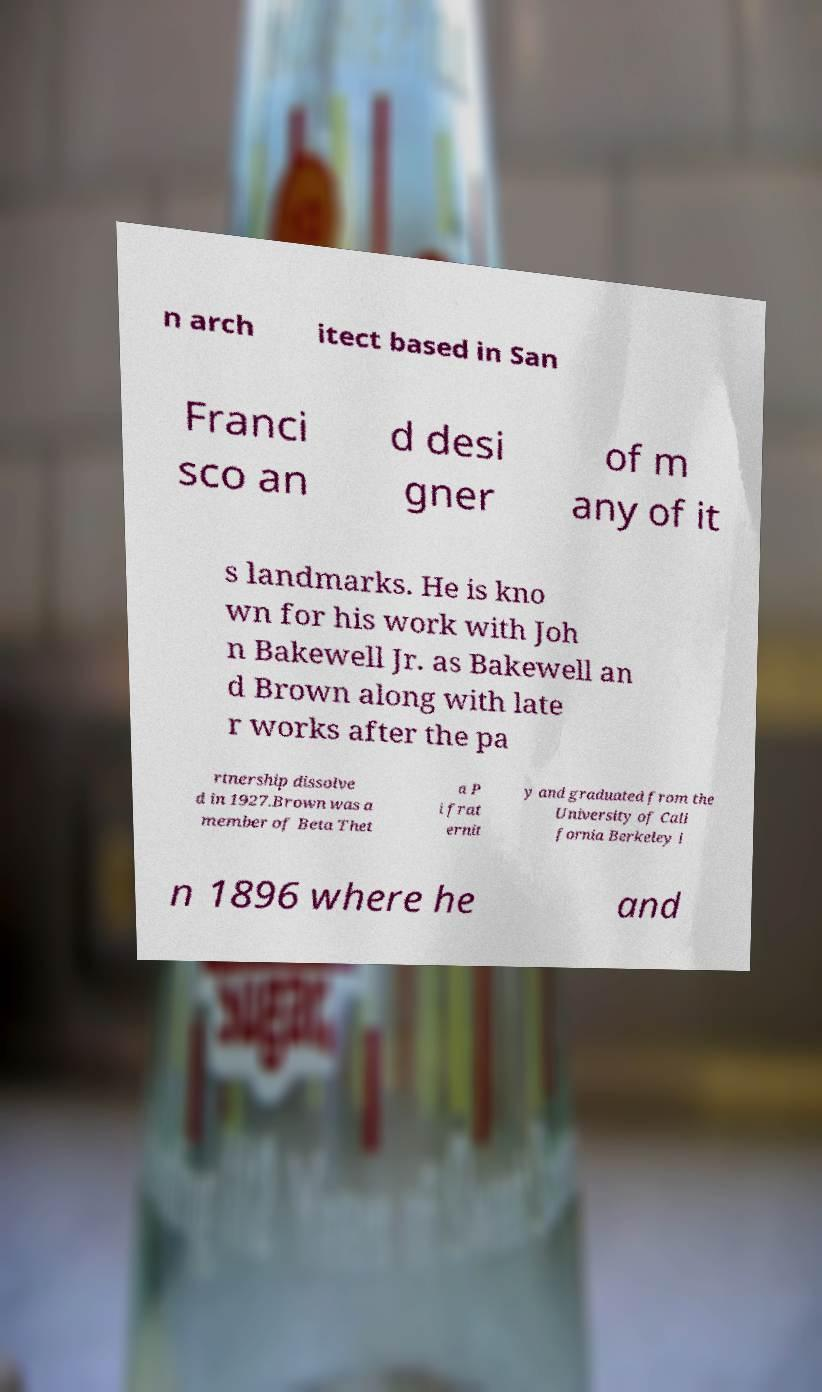Please read and relay the text visible in this image. What does it say? n arch itect based in San Franci sco an d desi gner of m any of it s landmarks. He is kno wn for his work with Joh n Bakewell Jr. as Bakewell an d Brown along with late r works after the pa rtnership dissolve d in 1927.Brown was a member of Beta Thet a P i frat ernit y and graduated from the University of Cali fornia Berkeley i n 1896 where he and 